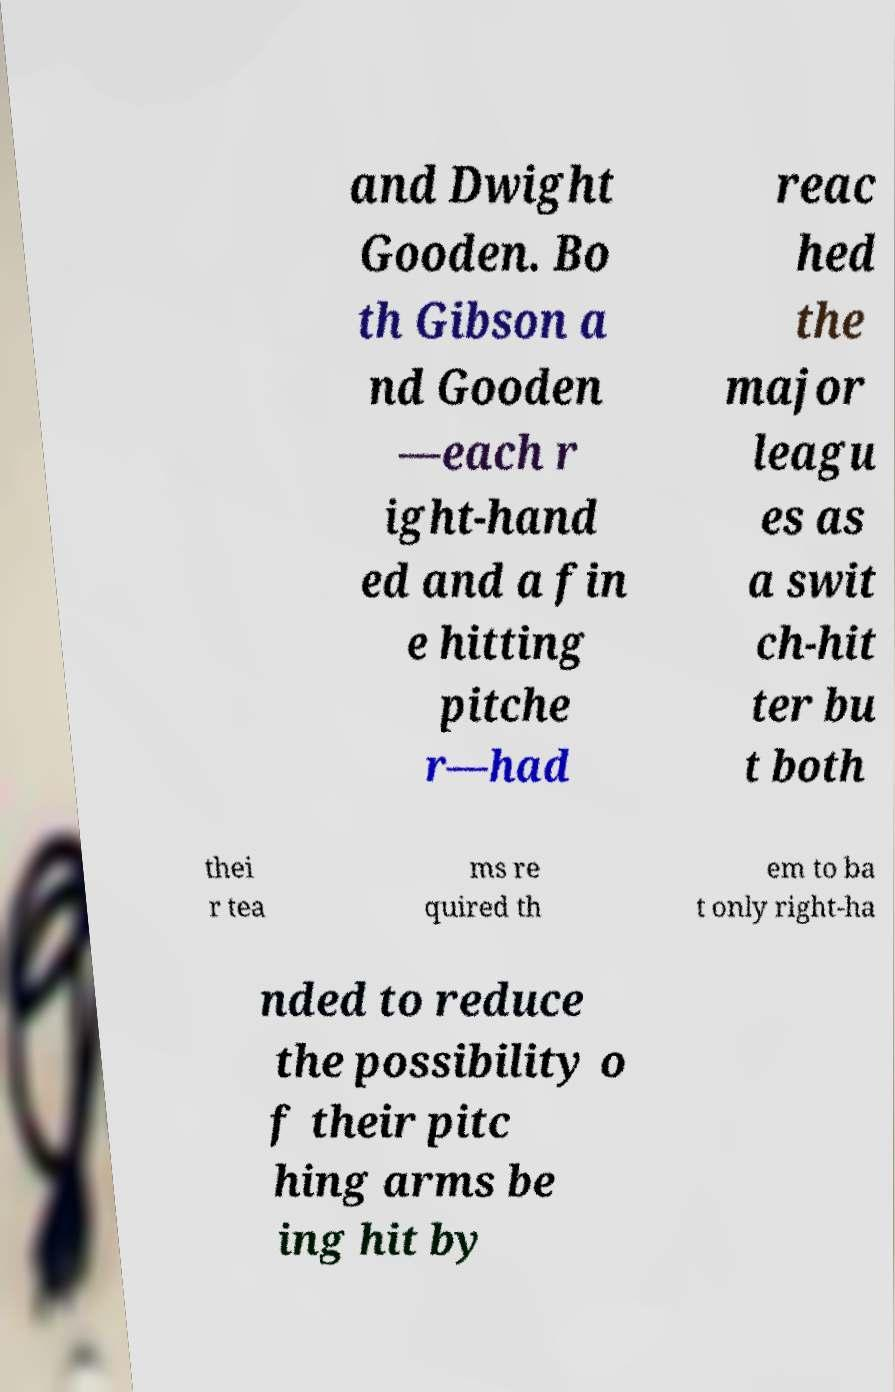For documentation purposes, I need the text within this image transcribed. Could you provide that? and Dwight Gooden. Bo th Gibson a nd Gooden —each r ight-hand ed and a fin e hitting pitche r—had reac hed the major leagu es as a swit ch-hit ter bu t both thei r tea ms re quired th em to ba t only right-ha nded to reduce the possibility o f their pitc hing arms be ing hit by 